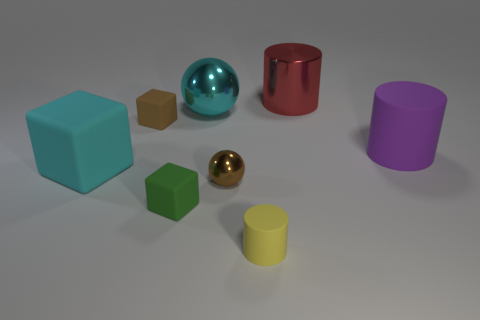Add 1 small brown cubes. How many objects exist? 9 Subtract all big cylinders. How many cylinders are left? 1 Add 7 cubes. How many cubes exist? 10 Subtract 1 green cubes. How many objects are left? 7 Subtract all balls. How many objects are left? 6 Subtract all small gray matte balls. Subtract all cyan metal objects. How many objects are left? 7 Add 4 green things. How many green things are left? 5 